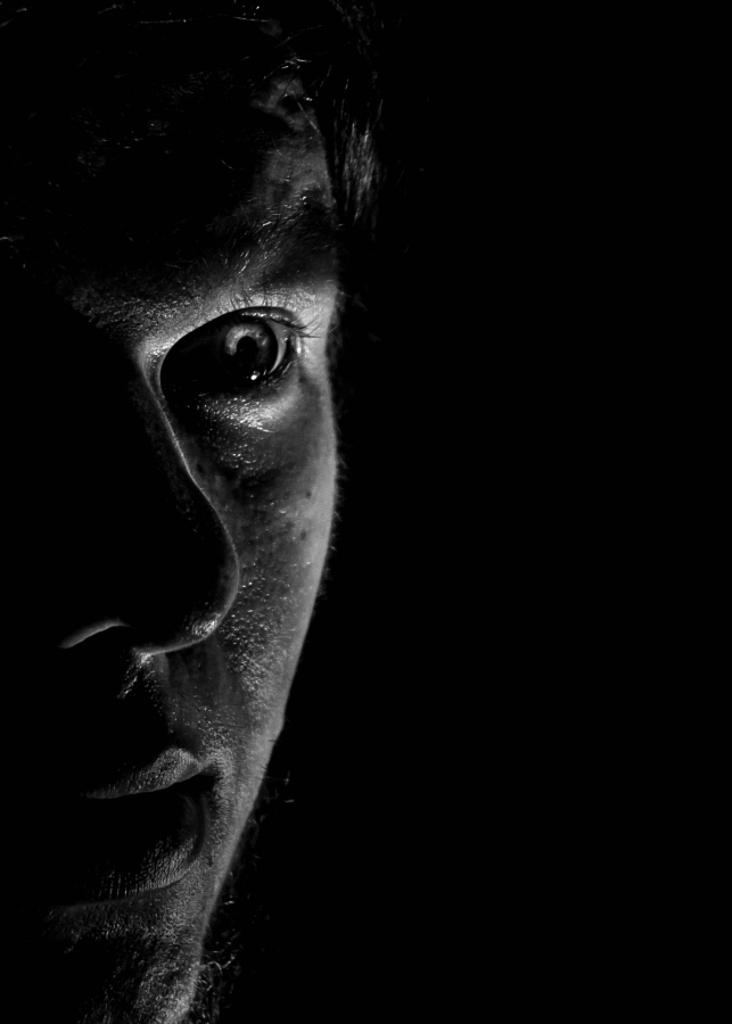What is the main subject of the image? There is a person's face in the image. Can you describe the background of the image? The background of the image is dark. What type of sponge is being used in the image? There is no sponge present in the image. What industry is depicted in the image? The image does not depict any industry; it features a person's face. 